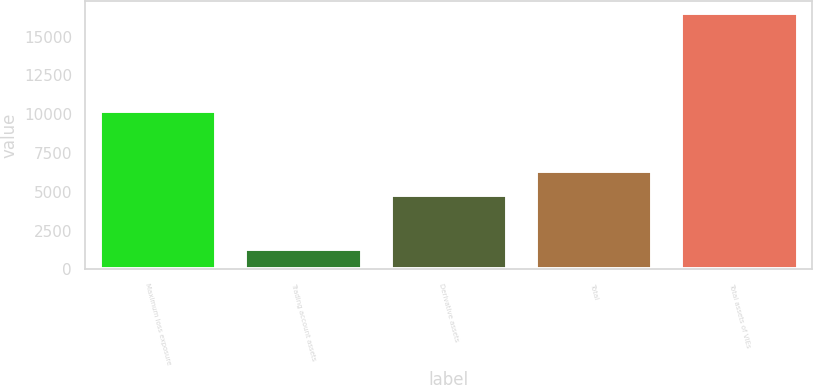<chart> <loc_0><loc_0><loc_500><loc_500><bar_chart><fcel>Maximum loss exposure<fcel>Trading account assets<fcel>Derivative assets<fcel>Total<fcel>Total assets of VIEs<nl><fcel>10229<fcel>1334<fcel>4815<fcel>6330.3<fcel>16487<nl></chart> 